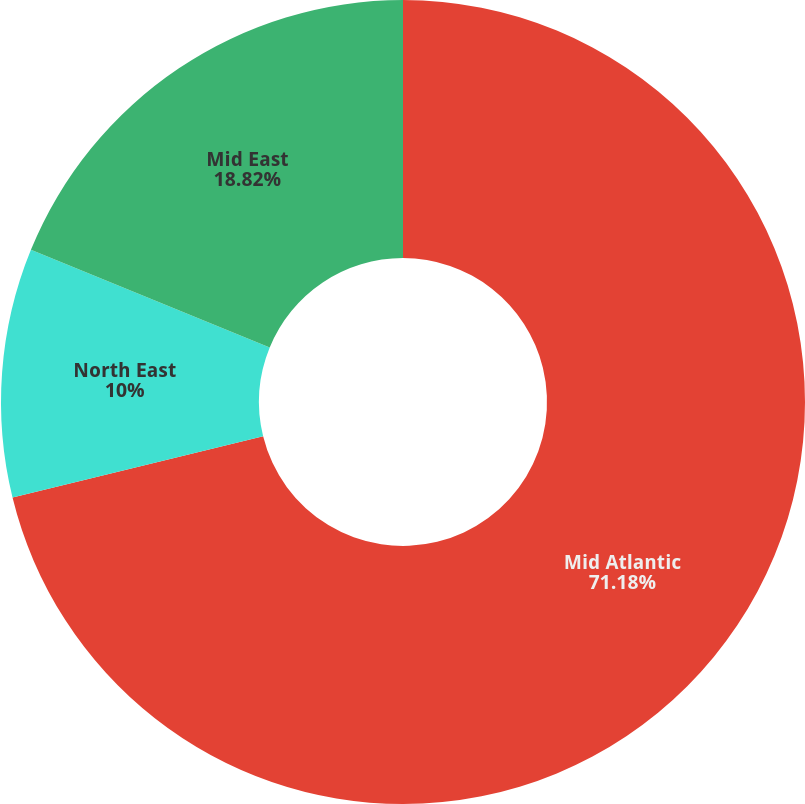Convert chart. <chart><loc_0><loc_0><loc_500><loc_500><pie_chart><fcel>Mid Atlantic<fcel>North East<fcel>Mid East<nl><fcel>71.18%<fcel>10.0%<fcel>18.82%<nl></chart> 